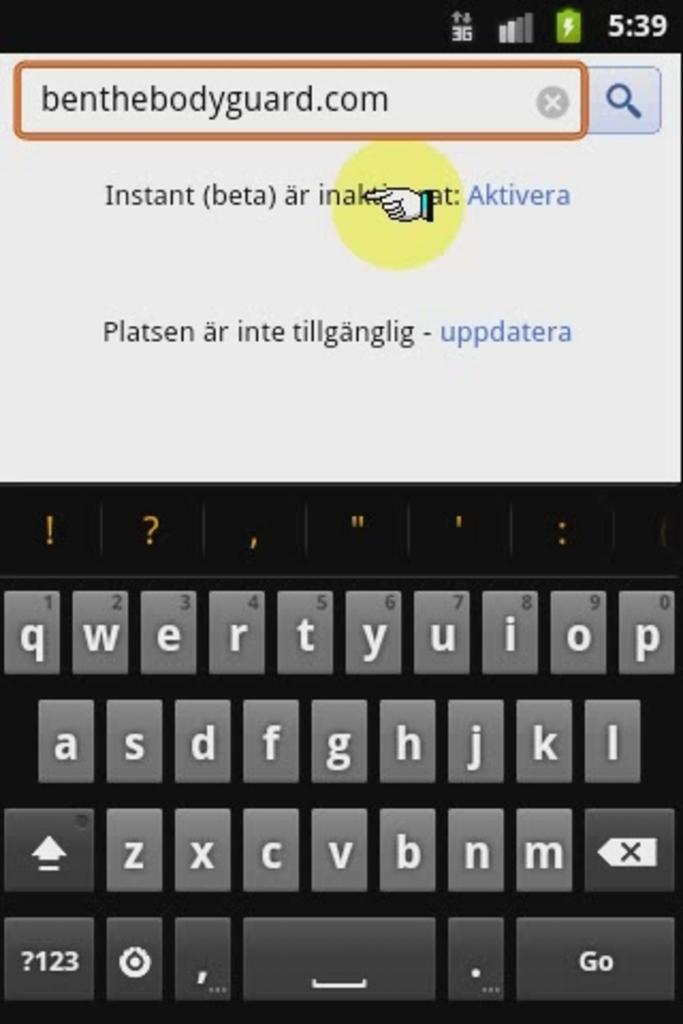<image>
Offer a succinct explanation of the picture presented. a picture of a keyboard with the word benthebodyguard.com at the top 